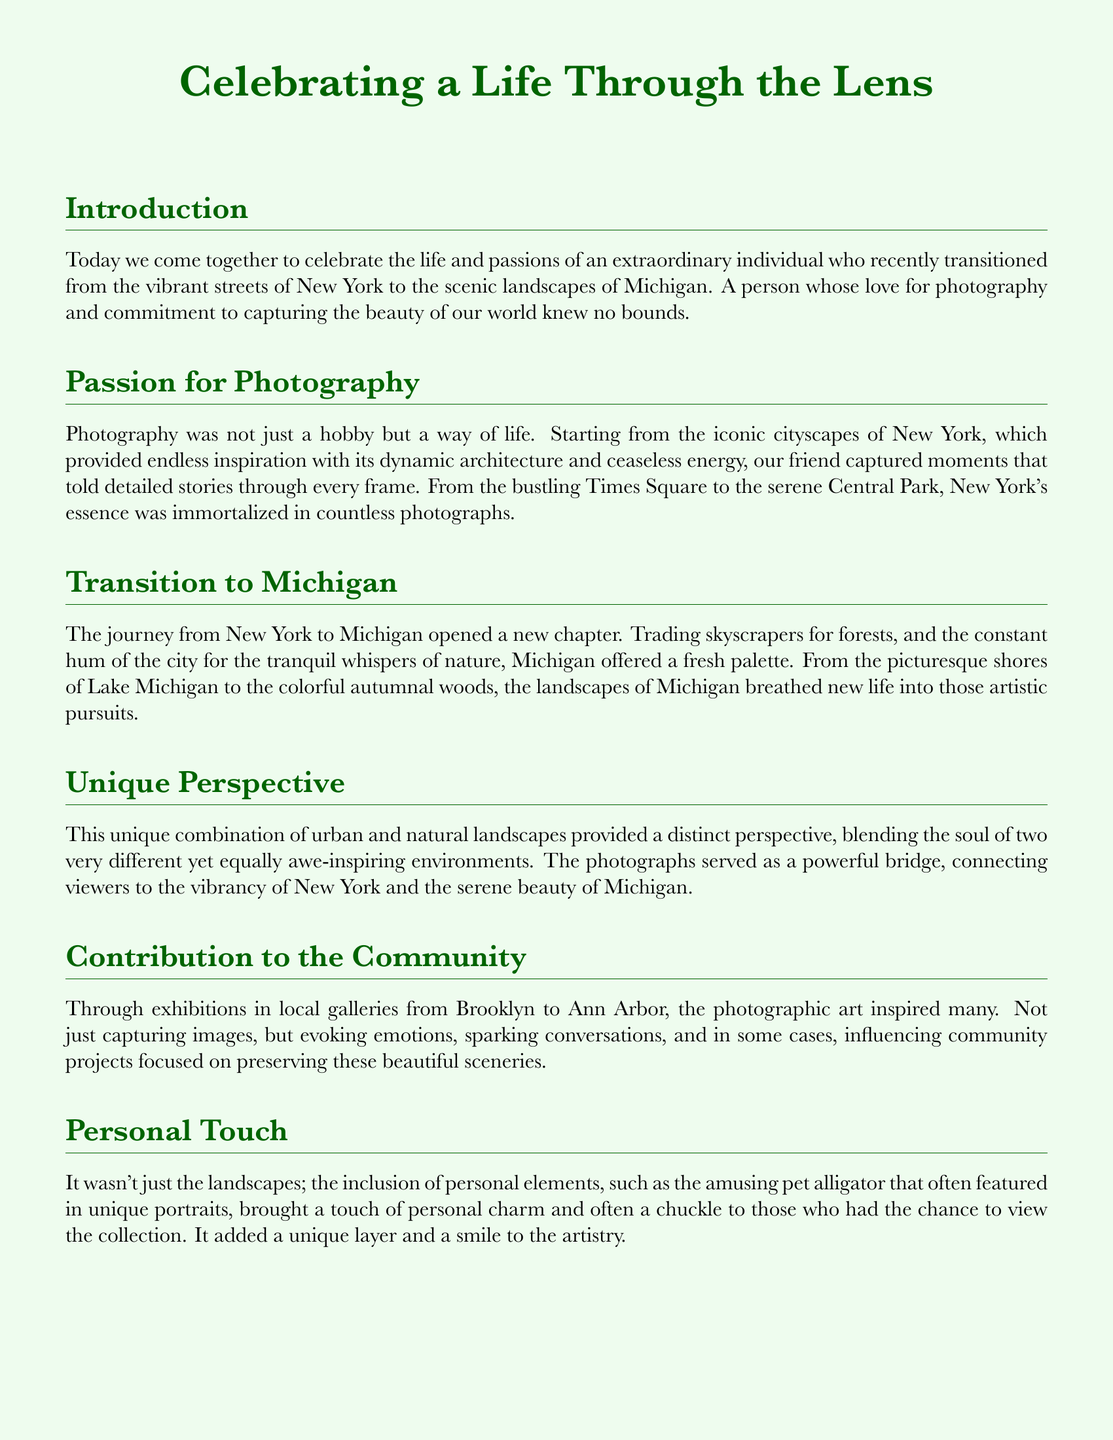What were the two locations highlighted in the eulogy? The eulogy celebrates the life and artistic contributions of an individual who transitioned from New York to Michigan, highlighting both landscapes.
Answer: New York, Michigan What type of art was emphasized in the eulogy? The document focuses on photography as a means of expression and celebration of nature and cityscapes.
Answer: Photography What aspect of New York's environment inspired the individual's work? The iconic cityscapes of New York provided endless inspiration noted in the document.
Answer: Cityscapes Which natural feature from Michigan was mentioned as a new inspiration? The lush landscapes of Michigan, particularly its vibrant autumnal woods and shores, were highlighted.
Answer: Lake Michigan What personal element added charm to the photography according to the eulogy? The document mentions the amusing pet alligator that often featured in portraits, bringing a unique touch.
Answer: Pet alligator How did the individual's photography influence the community? Exhibitions in local galleries sparked conversations and influenced community projects focused on preserving scenery.
Answer: Inspired community projects What did the individual's photography serve as a bridge between? The photographs connected viewers to the vibrancy of New York and the serene beauty of Michigan.
Answer: New York and Michigan What was the overall purpose of the eulogy? The eulogy aimed to celebrate a life lived fully through photography, highlighting moments captured through the lens.
Answer: Celebrate life through photography 